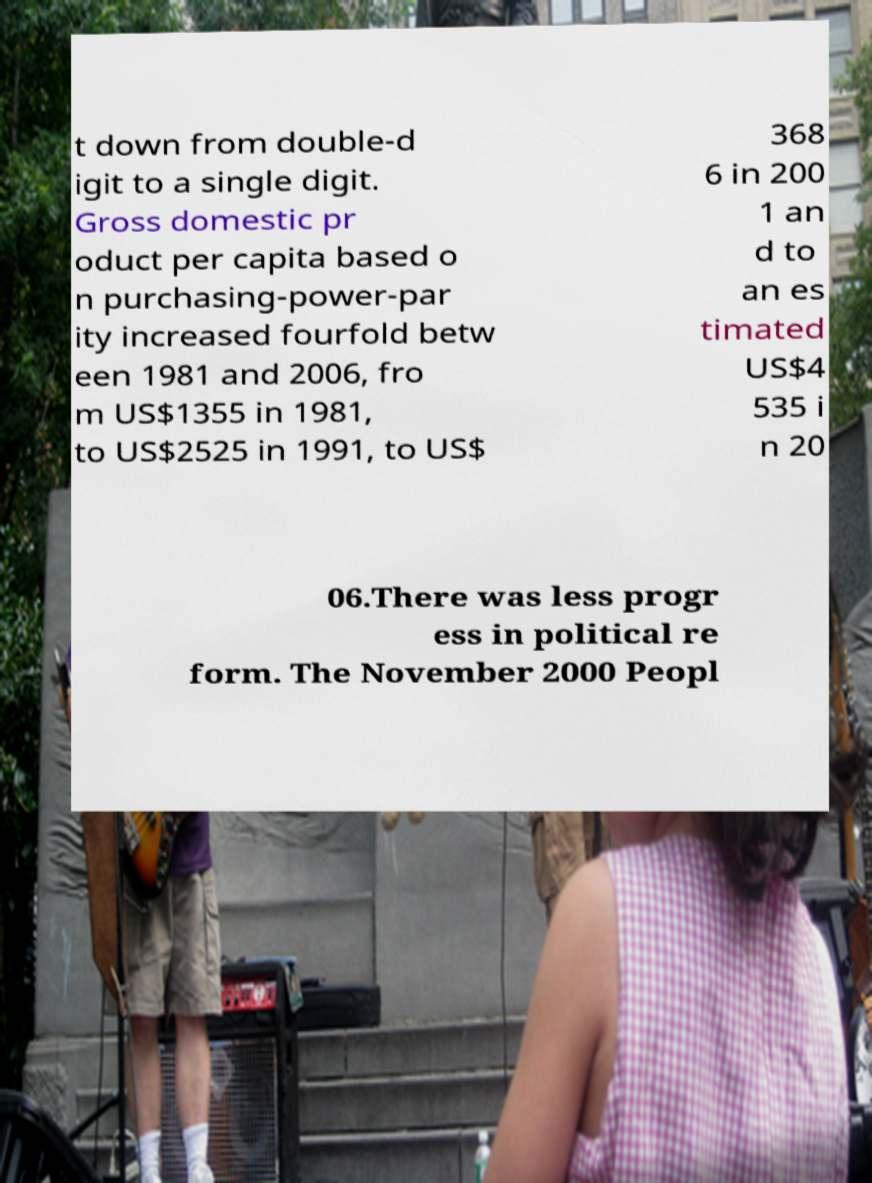Could you extract and type out the text from this image? t down from double-d igit to a single digit. Gross domestic pr oduct per capita based o n purchasing-power-par ity increased fourfold betw een 1981 and 2006, fro m US$1355 in 1981, to US$2525 in 1991, to US$ 368 6 in 200 1 an d to an es timated US$4 535 i n 20 06.There was less progr ess in political re form. The November 2000 Peopl 